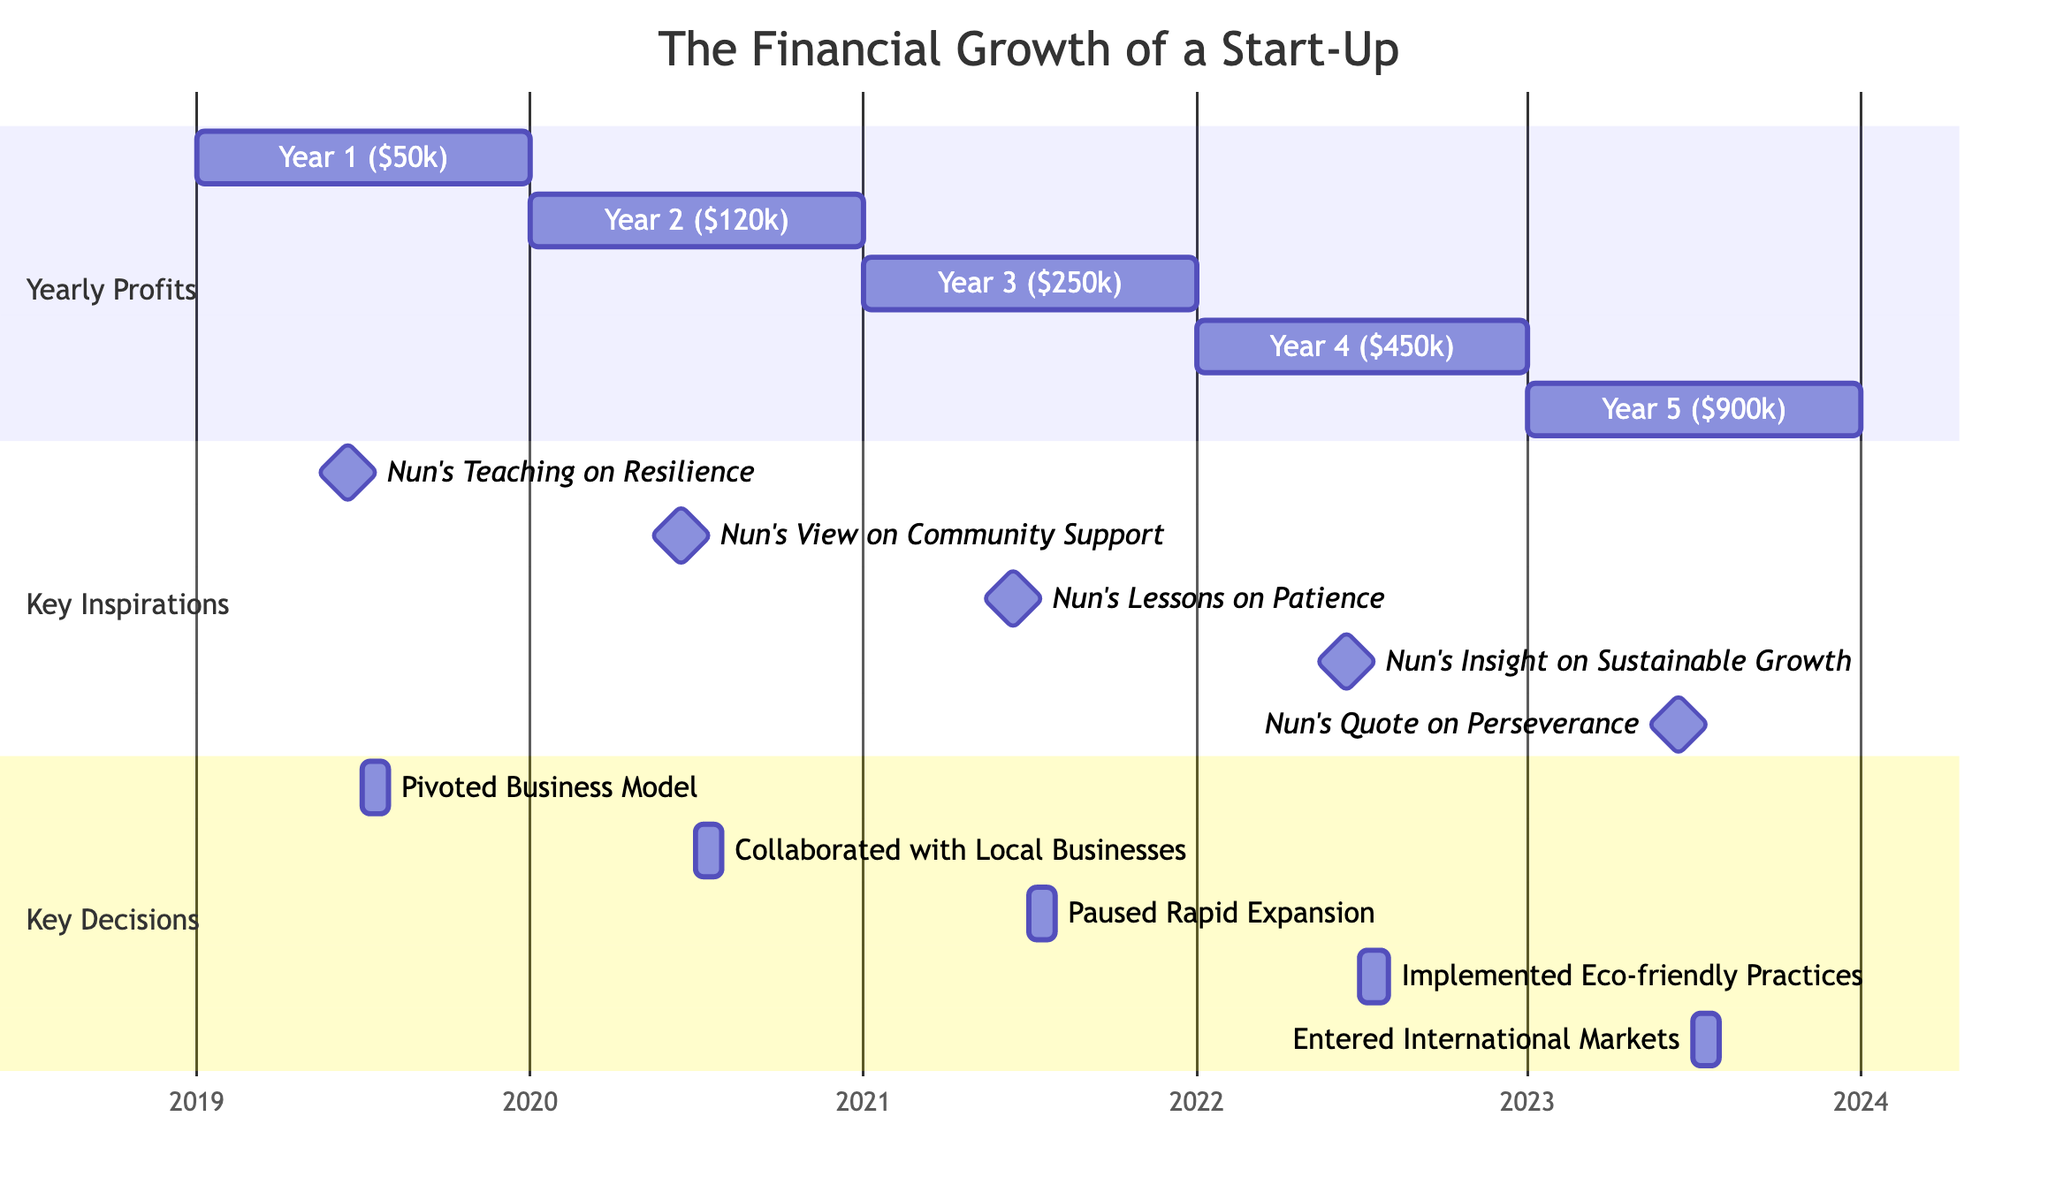What was the profit in Year 3? According to the diagram, Year 3 corresponds to 2021, where the profit is listed as $250k.
Answer: $250k What is the key moment of inspiration in Year 5? In Year 5 (2023), the key moment of inspiration is the "Nun's Quote on Perseverance," which is highlighted at the milestone.
Answer: Nun's Quote on Perseverance Which year had the lowest profit? By comparing the yearly profits listed, Year 1 (2019) has the lowest amount at $50k.
Answer: $50k How many key decisions are noted in the diagram? The diagram lists five key decisions made, as shown in the "Key Decisions" section.
Answer: 5 What does the "Nun's Insight on Sustainable Growth" refer to? "Nun's Insight on Sustainable Growth" is a key moment of inspiration that appears in Year 4, specifically on June 15, 2022, signifying the lessons learned about developing a long-term sustainable approach to business.
Answer: Nun's Insight on Sustainable Growth In which year was the business model pivoted? The business model was pivoted in Year 1, specifically noted on July 1, 2019.
Answer: Year 1 What is the significance of the "Collaborated with Local Businesses" decision? This decision, noted on July 1, 2020, represents a strategic collaboration to leverage local resources and support, reflecting the influence of the nun's teachings on community support.
Answer: Collaborated with Local Businesses Which year shows the highest profit? The highest profit is shown in Year 5 (2023), which amounts to $900k.
Answer: $900k What key lesson was highlighted in June 2021? In June 2021, the key lesson highlighted is "Nun's Lessons on Patience," which is indicated as important at that milestone.
Answer: Nun's Lessons on Patience 